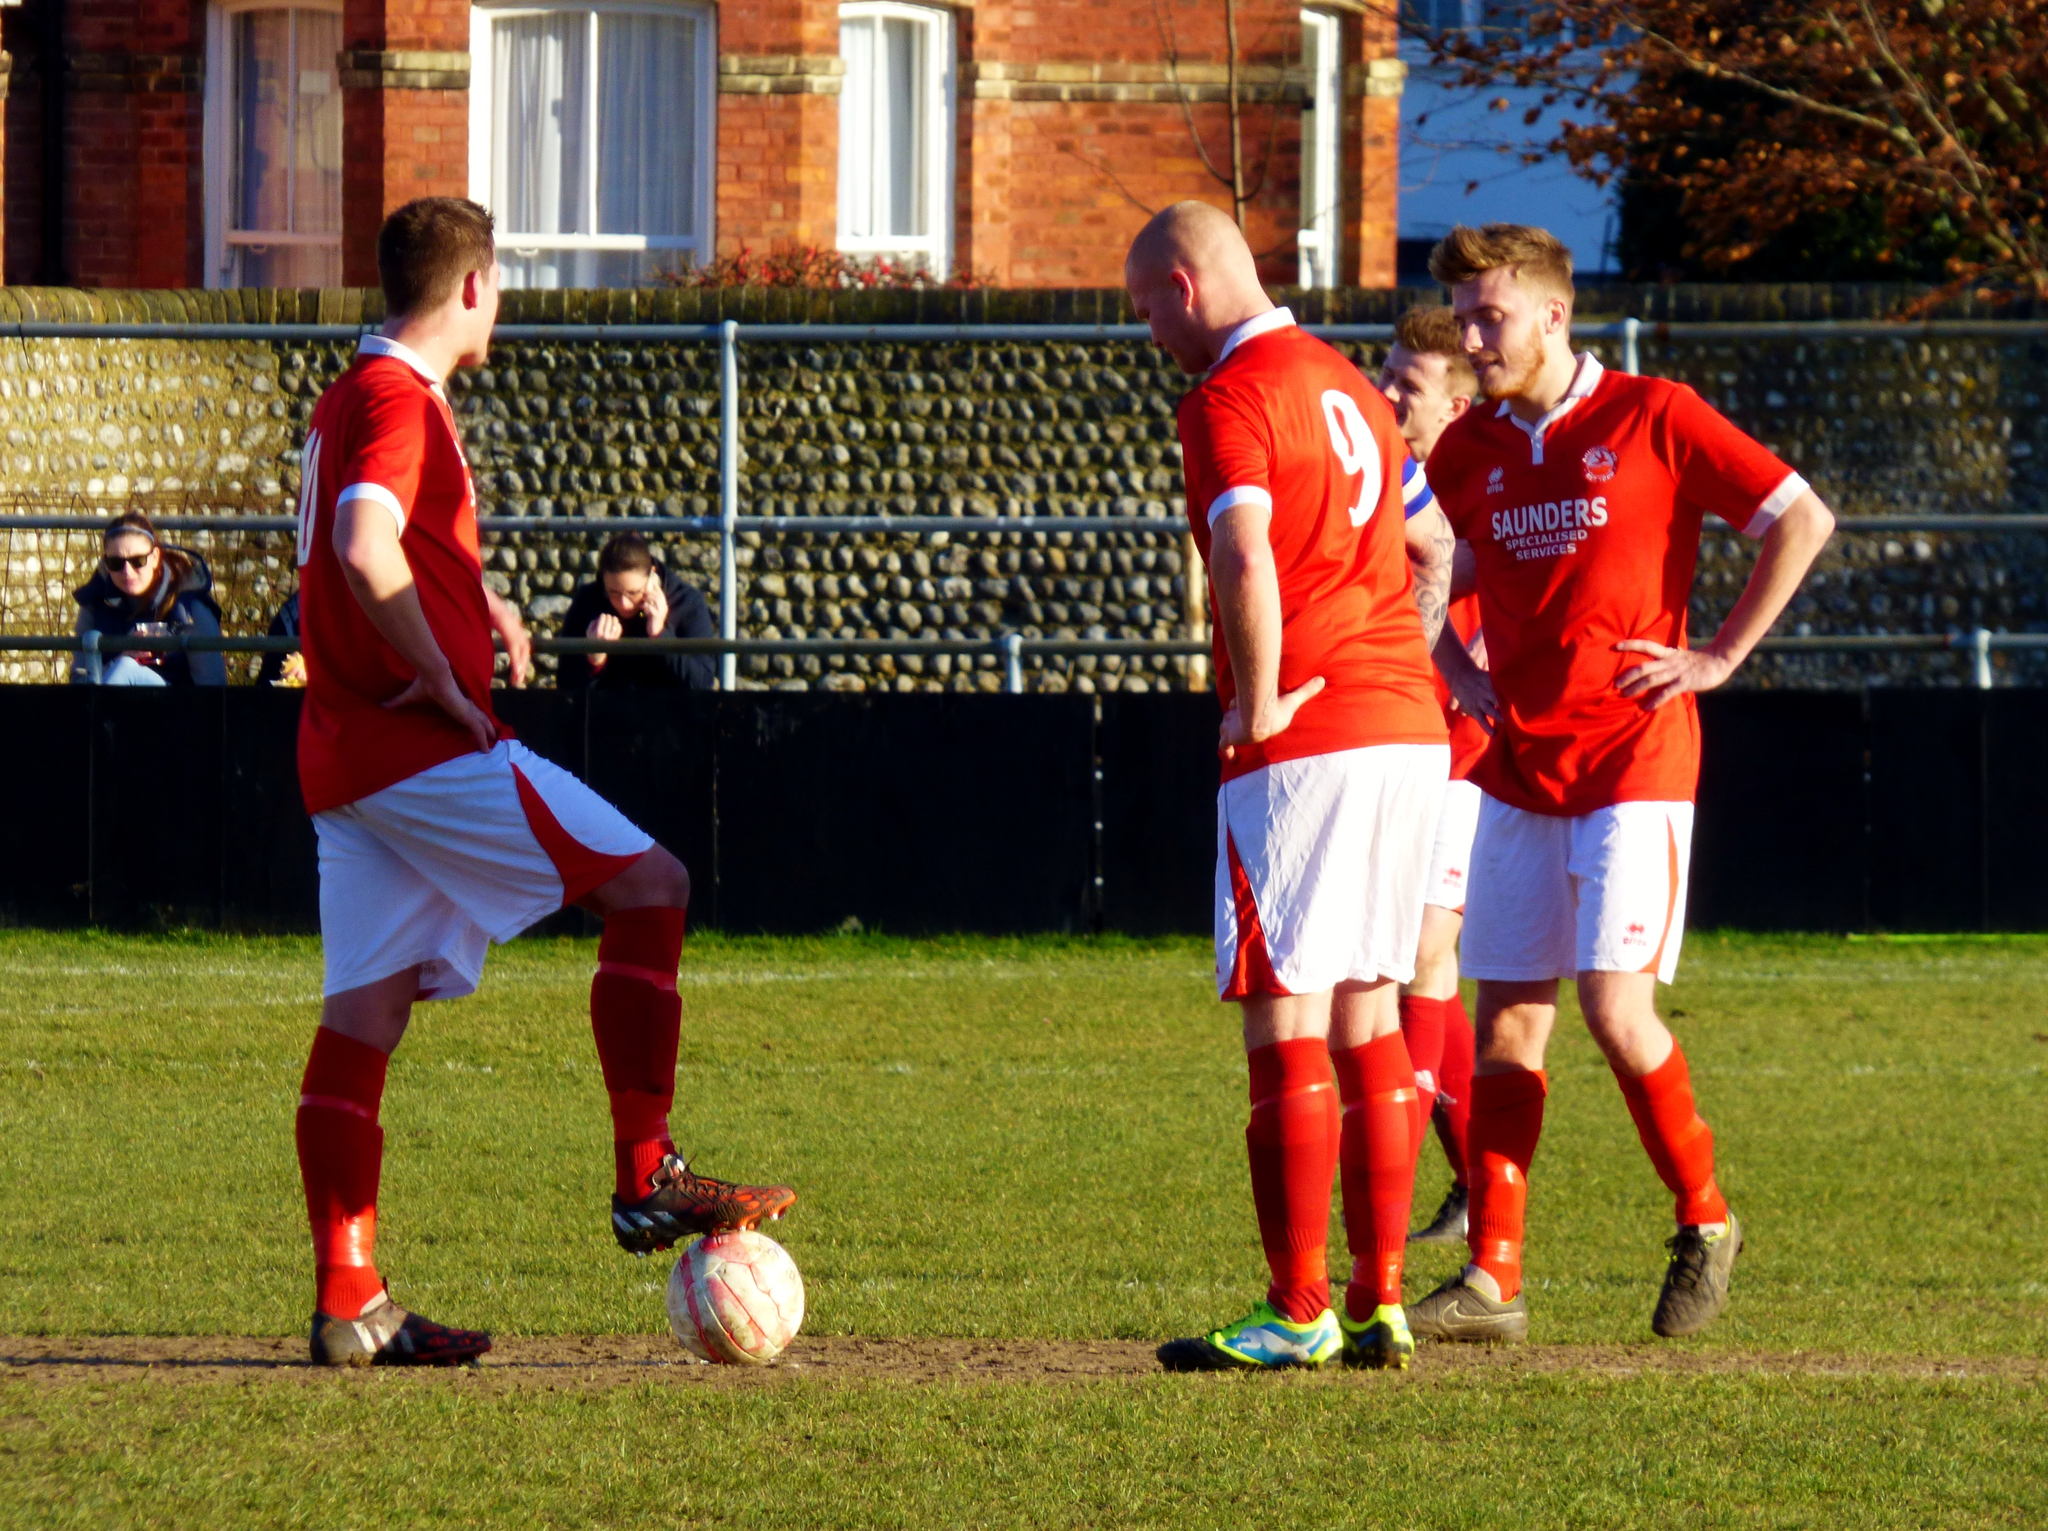<image>
Summarize the visual content of the image. A group of male soccer players standing together on the field wearing orange and white shirts with sponsor, Saunders Specialized Services, printed on the front. 